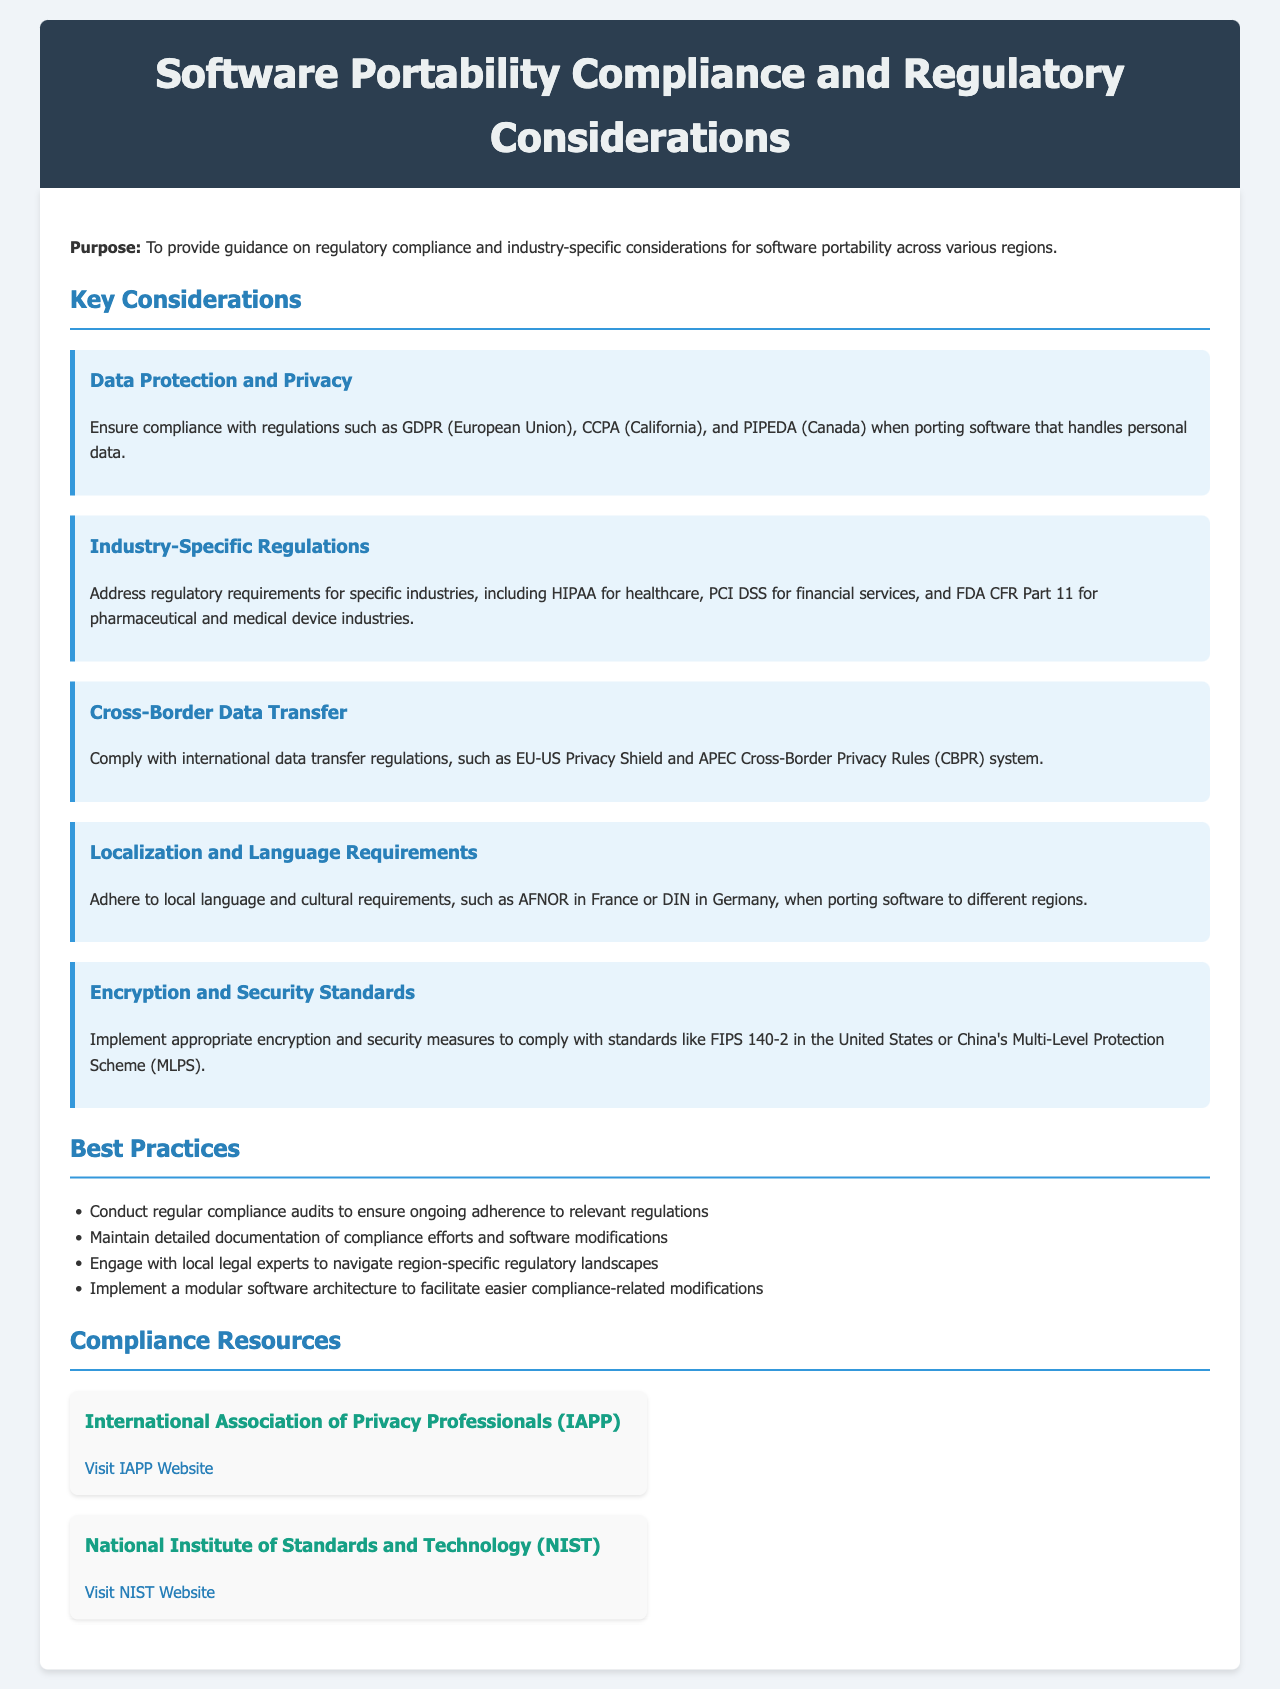What are the data protection regulations mentioned? The document lists GDPR, CCPA, and PIPEDA as data protection regulations for software portability.
Answer: GDPR, CCPA, PIPEDA Which regulation applies to the healthcare industry? HIPAA is specified as the regulation relevant to the healthcare industry in the document.
Answer: HIPAA What is the purpose of this policy document? The purpose is stated in the introduction, focusing on regulatory compliance and industry-specific considerations for software portability.
Answer: Guidance on regulatory compliance What encryption standard is mentioned for the United States? FIPS 140-2 is identified as an encryption and security standard for compliance in the United States.
Answer: FIPS 140-2 Which resource can provide information on privacy professionals? The International Association of Privacy Professionals (IAPP) is mentioned as a resource for privacy professionals.
Answer: IAPP What is a recommended best practice for compliance? Engaging with local legal experts to navigate region-specific regulatory landscapes is one of the best practices mentioned.
Answer: Engage with local legal experts What does "CBPR" stand for in the context of data transfer regulations? The document refers to the APEC Cross-Border Privacy Rules (CBPR) system related to international data transfer regulations.
Answer: Cross-Border Privacy Rules What type of software architecture is suggested for compliance modifications? The document suggests implementing a modular software architecture to facilitate compliance-related modifications.
Answer: Modular software architecture How many compliance resources are listed in the document? Two compliance resources are provided in the resources section of the document.
Answer: Two 